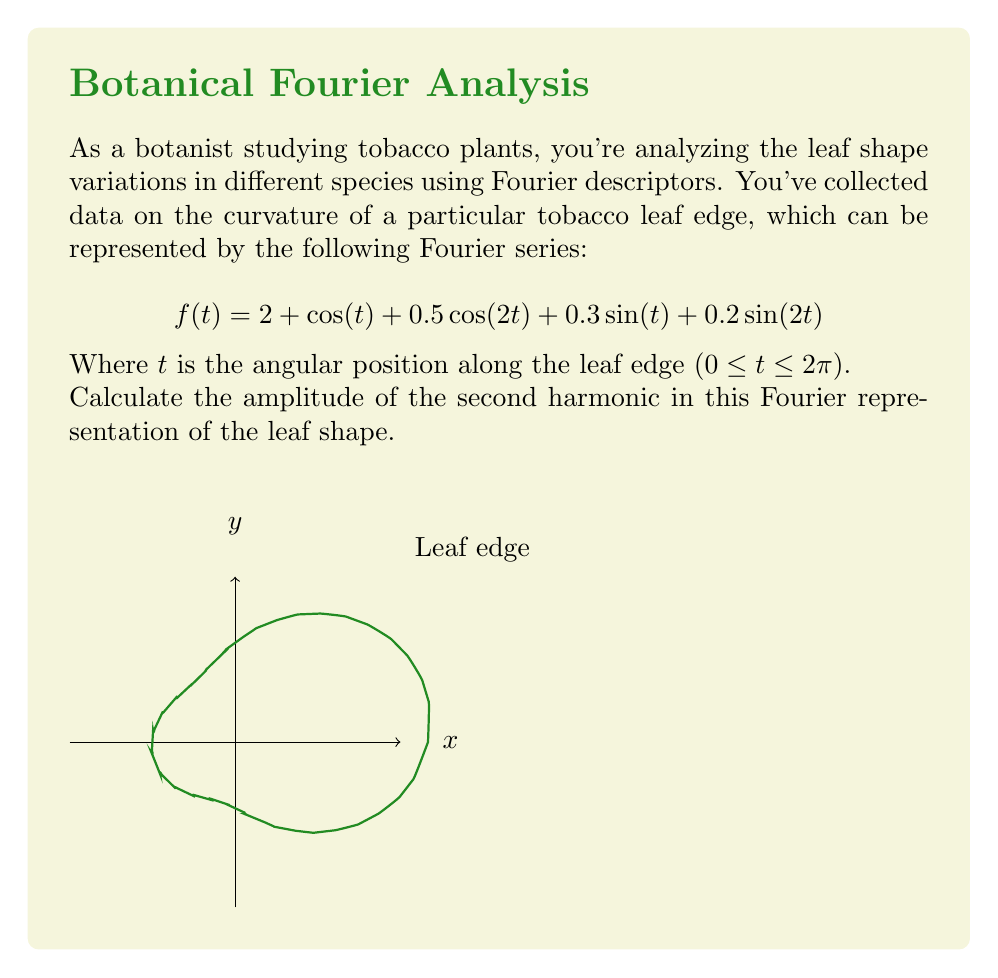Solve this math problem. To find the amplitude of the second harmonic in the Fourier representation, we need to follow these steps:

1) Recall that a general Fourier series can be written as:
   $$f(t) = a_0 + \sum_{n=1}^{\infty} (a_n\cos(nt) + b_n\sin(nt))$$

2) In our given function:
   $$f(t) = 2 + \cos(t) + 0.5\cos(2t) + 0.3\sin(t) + 0.2\sin(2t)$$

3) Comparing this with the general form, we can identify:
   $a_0 = 2$
   $a_1 = 1$, $b_1 = 0.3$
   $a_2 = 0.5$, $b_2 = 0.2$

4) The second harmonic corresponds to the terms with $n=2$, which are:
   $$0.5\cos(2t) + 0.2\sin(2t)$$

5) The amplitude of a harmonic is given by the square root of the sum of squares of its cosine and sine coefficients:
   $$\text{Amplitude} = \sqrt{a_n^2 + b_n^2}$$

6) For the second harmonic ($n=2$):
   $$\text{Amplitude} = \sqrt{a_2^2 + b_2^2} = \sqrt{0.5^2 + 0.2^2}$$

7) Calculating:
   $$\sqrt{0.5^2 + 0.2^2} = \sqrt{0.25 + 0.04} = \sqrt{0.29} \approx 0.5385$$

Therefore, the amplitude of the second harmonic is approximately 0.5385.
Answer: $\sqrt{0.5^2 + 0.2^2} \approx 0.5385$ 